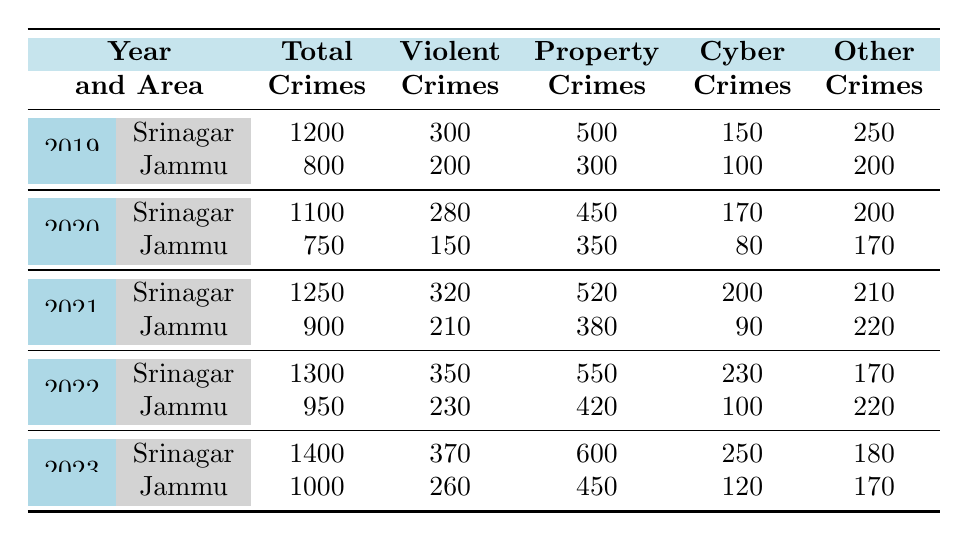What was the total number of violent crimes in Srinagar in 2022? In the table, we look for the row corresponding to Srinagar in the year 2022, which shows that there were 350 violent crimes.
Answer: 350 How many total crimes were reported in Jammu in 2020? For Jammu in 2020, the table indicates that the number of total crimes was 750.
Answer: 750 What is the trend in total crimes from 2019 to 2023 for Srinagar? To identify the trend, we can note the total crimes in Srinagar for each year: 1200 (2019), 1100 (2020), 1250 (2021), 1300 (2022), and 1400 (2023). The trend shows an overall increase in total crimes over these years.
Answer: Increase Was there a decrease in property crimes in Jammu from 2019 to 2020? By examining the property crimes in Jammu, in 2019 it was 300, and in 2020 it was 350. Since 350 is greater than 300, there was no decrease.
Answer: No What was the average number of cyber crimes reported in Srinagar from 2019 to 2023? The number of cyber crimes in Srinagar are: 150 (2019), 170 (2020), 200 (2021), 230 (2022), and 250 (2023). Summing these gives 1070. Dividing by 5 (the number of years) gives an average of 214.
Answer: 214 How many more violent crimes were reported in Jammu in 2023 compared to 2022? For Jammu in 2023, the violent crimes were 260 and in 2022, it was 230. The difference is 260 - 230 = 30 more violent crimes in 2023 compared to 2022.
Answer: 30 Did the total number of crimes in Srinagar surpass those in Jammu in every year from 2019 to 2023? Comparing the total crimes: Srinagar (2019) 1200 vs Jammu (800), Sri (2020) 1100 vs Jam (750), Sri (2021) 1250 vs Jam (900), Sri (2022) 1300 vs Jam (950), Sri (2023) 1400 vs Jam (1000). Srinagar’s total crimes were consistently higher each year.
Answer: Yes What was the maximum number of property crimes reported in a single year for either city? Looking at the property crimes, they are: 500 (Srinagar 2019), 450 (Srinagar 2020), 520 (Srinagar 2021), 550 (Srinagar 2022), 600 (Srinagar 2023), 300 (Jammu 2019), 350 (Jammu 2020), 380 (Jammu 2021), 420 (Jammu 2022), 450 (Jammu 2023). The maximum occurs in Srinagar in 2023 with 600.
Answer: 600 What percentage of total crimes in Srinagar in 2021 were violent crimes? In 2021, Srinagar had 1250 total crimes, with 320 of them being violent. To calculate the percentage: (320 / 1250) * 100 = 25.6%.
Answer: 25.6% 